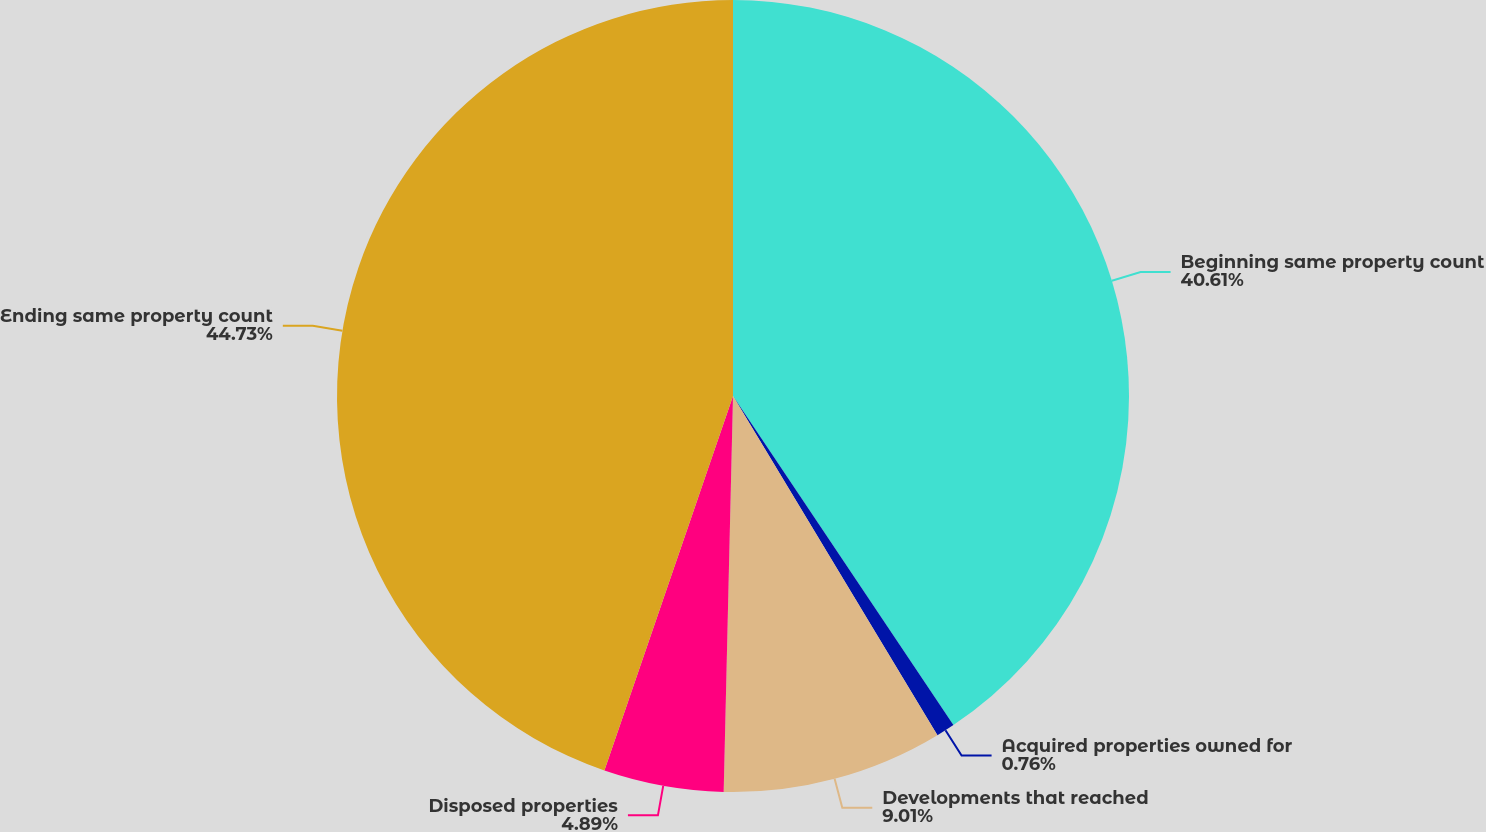Convert chart. <chart><loc_0><loc_0><loc_500><loc_500><pie_chart><fcel>Beginning same property count<fcel>Acquired properties owned for<fcel>Developments that reached<fcel>Disposed properties<fcel>Ending same property count<nl><fcel>40.61%<fcel>0.76%<fcel>9.01%<fcel>4.89%<fcel>44.74%<nl></chart> 